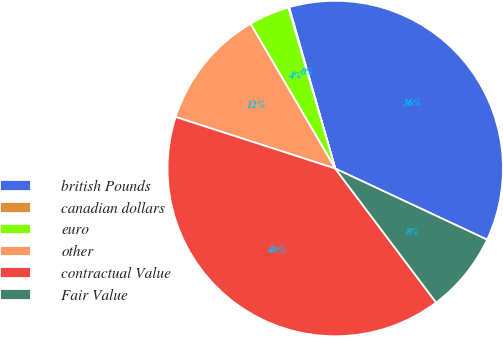Convert chart. <chart><loc_0><loc_0><loc_500><loc_500><pie_chart><fcel>british Pounds<fcel>canadian dollars<fcel>euro<fcel>other<fcel>contractual Value<fcel>Fair Value<nl><fcel>36.41%<fcel>0.08%<fcel>3.92%<fcel>11.6%<fcel>40.25%<fcel>7.76%<nl></chart> 